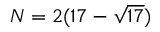<formula> <loc_0><loc_0><loc_500><loc_500>N = 2 ( 1 7 - { \sqrt { 1 7 } } )</formula> 